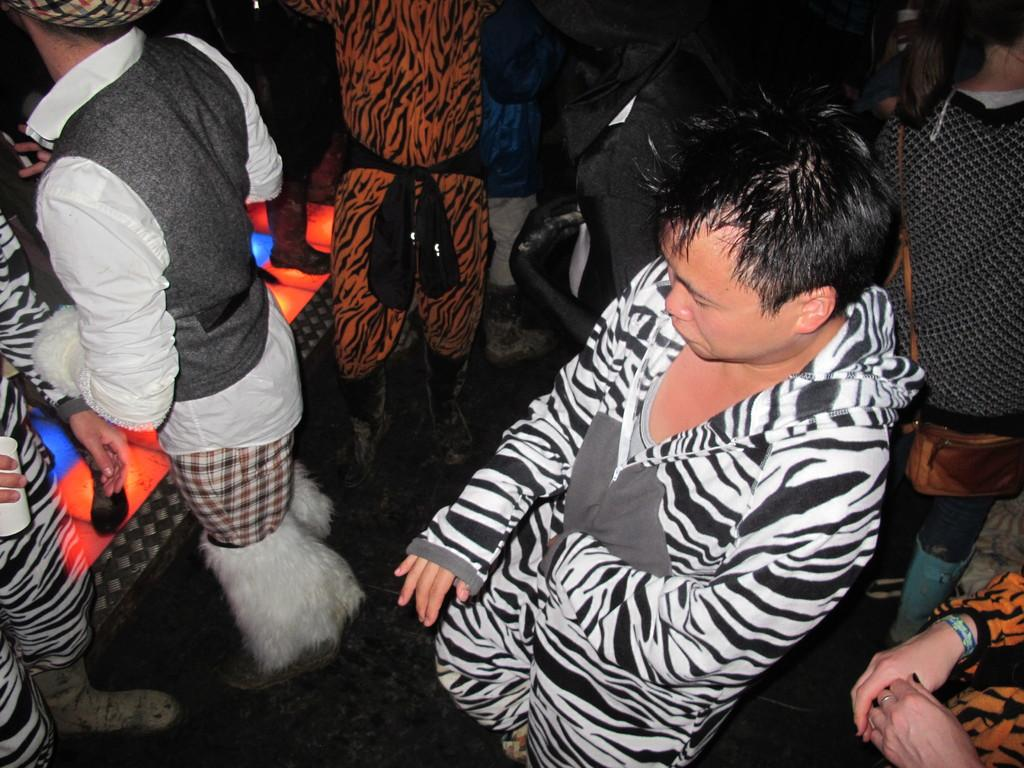Who or what can be seen in the image? There are people in the image. What are the people wearing? The people are wearing different costumes. Where are the people standing? The people are standing on the floor. What type of wire can be seen connecting the people in the image? There is no wire connecting the people in the image; they are simply standing on the floor. 